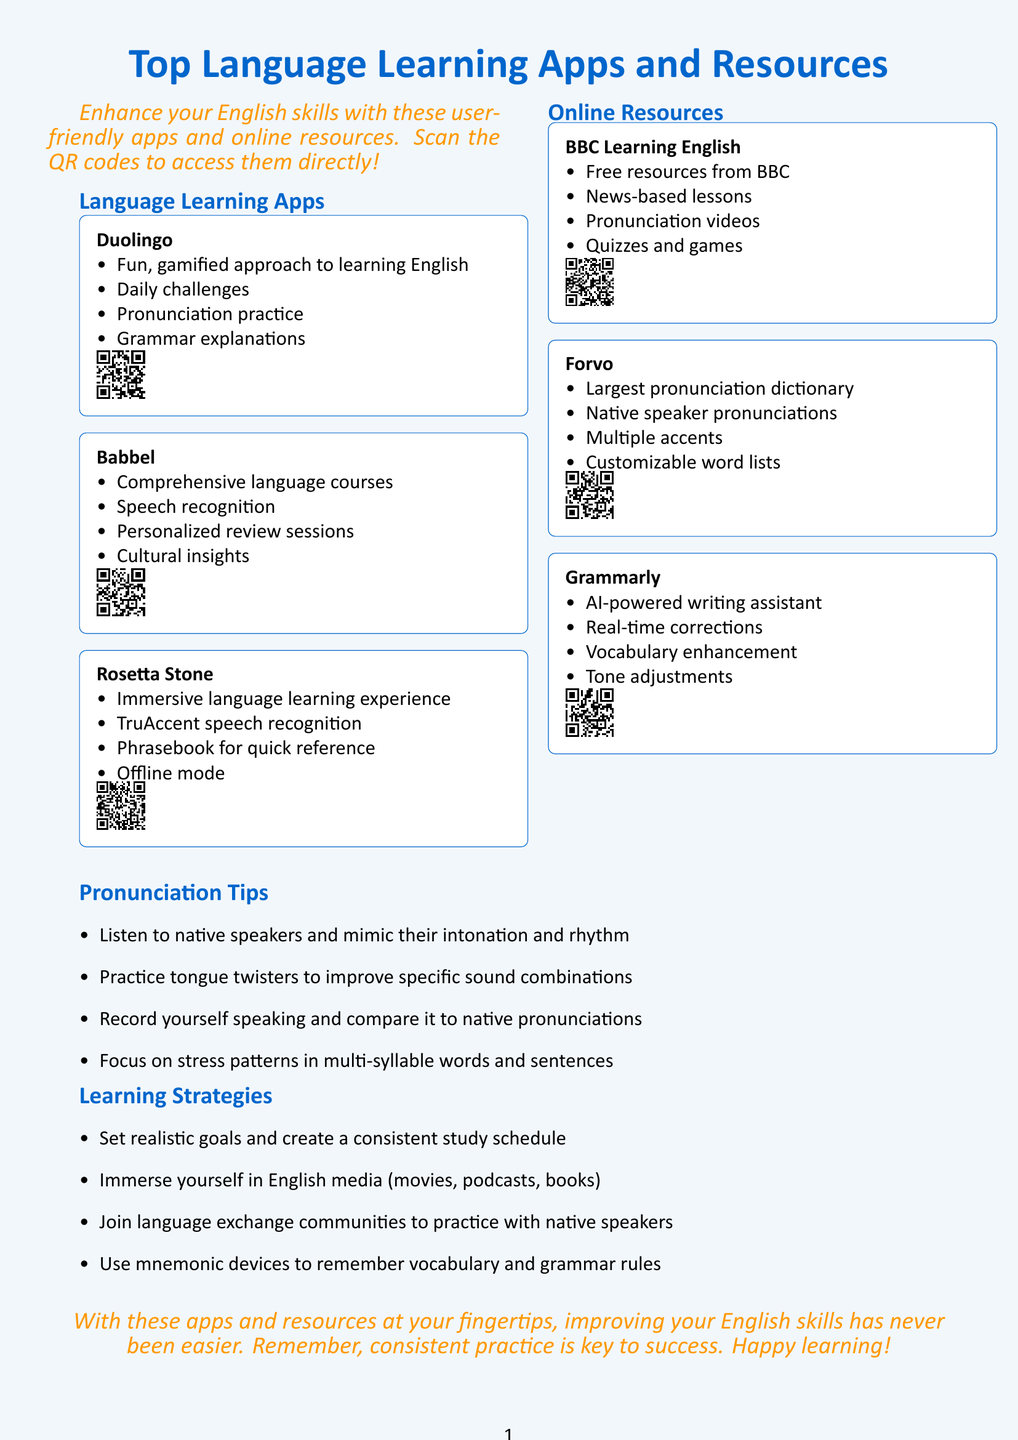What is the title of the brochure? The title summarizes the content and purpose of the brochure, which is focused on language learning.
Answer: Top Language Learning Apps and Resources for Non-Native English Speakers How many language learning apps are featured in the brochure? The brochure lists specific apps, indicating the available resources.
Answer: Three What is a feature of Duolingo? This asks for specific information about one of the apps highlighted in the brochure.
Answer: Daily challenges What type of resource is Forvo? The question pertains to the classification of a specific resource mentioned in the document.
Answer: Pronunciation dictionary What do the pronunciation tips focus on? The tips provided are directed towards specific aspects of improving pronunciation.
Answer: Stress patterns Which application provides speech recognition? This question highlights a common feature shared by the apps discussed in the brochure.
Answer: Babbel How does the brochure suggest improving writing skills? This question requires understanding the services offered by one of the resources.
Answer: Grammarly What is the main goal of the document? This question identifies the overarching purpose intended by the brochure's content.
Answer: Improving English skills 